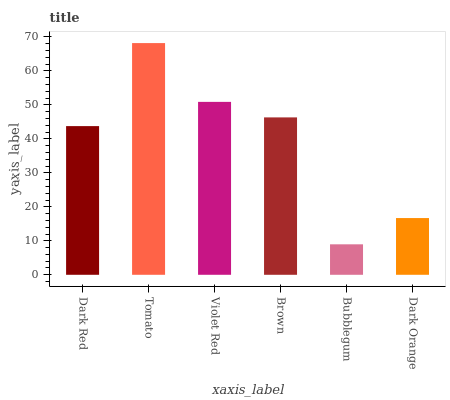Is Bubblegum the minimum?
Answer yes or no. Yes. Is Tomato the maximum?
Answer yes or no. Yes. Is Violet Red the minimum?
Answer yes or no. No. Is Violet Red the maximum?
Answer yes or no. No. Is Tomato greater than Violet Red?
Answer yes or no. Yes. Is Violet Red less than Tomato?
Answer yes or no. Yes. Is Violet Red greater than Tomato?
Answer yes or no. No. Is Tomato less than Violet Red?
Answer yes or no. No. Is Brown the high median?
Answer yes or no. Yes. Is Dark Red the low median?
Answer yes or no. Yes. Is Bubblegum the high median?
Answer yes or no. No. Is Bubblegum the low median?
Answer yes or no. No. 